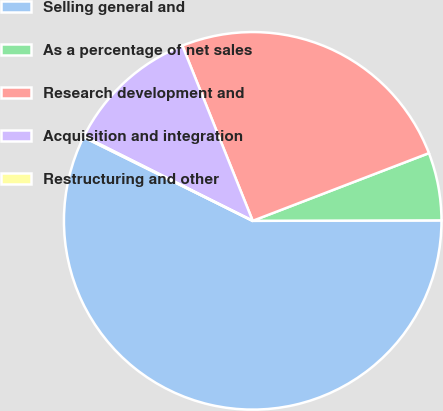Convert chart to OTSL. <chart><loc_0><loc_0><loc_500><loc_500><pie_chart><fcel>Selling general and<fcel>As a percentage of net sales<fcel>Research development and<fcel>Acquisition and integration<fcel>Restructuring and other<nl><fcel>57.34%<fcel>5.8%<fcel>25.24%<fcel>11.53%<fcel>0.08%<nl></chart> 